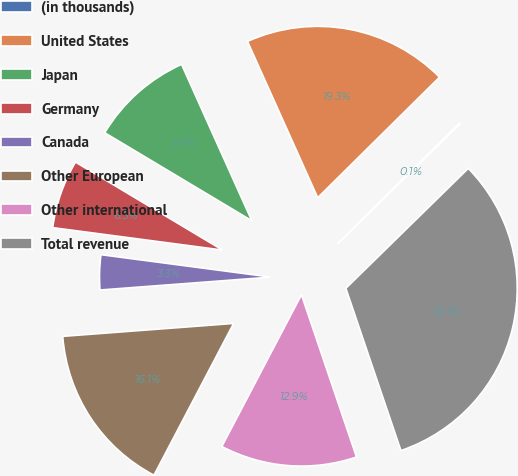Convert chart to OTSL. <chart><loc_0><loc_0><loc_500><loc_500><pie_chart><fcel>(in thousands)<fcel>United States<fcel>Japan<fcel>Germany<fcel>Canada<fcel>Other European<fcel>Other international<fcel>Total revenue<nl><fcel>0.08%<fcel>19.31%<fcel>9.7%<fcel>6.49%<fcel>3.29%<fcel>16.11%<fcel>12.9%<fcel>32.13%<nl></chart> 